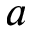Convert formula to latex. <formula><loc_0><loc_0><loc_500><loc_500>a</formula> 